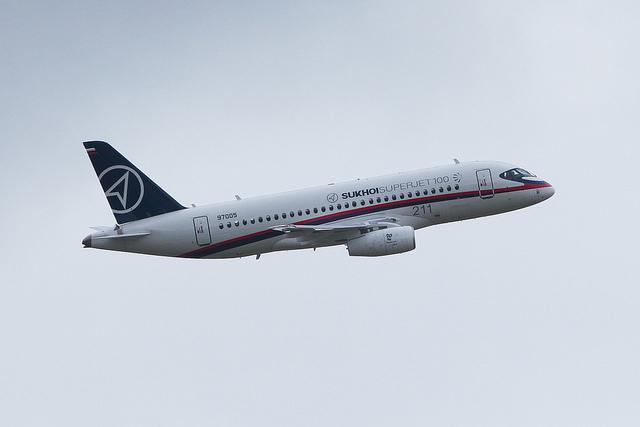What are the colors of the plane?
Write a very short answer. White, blue, red. Is the plane ready to land?
Keep it brief. No. How many engines are seen?
Write a very short answer. 1. Is the landing gear up or down?
Write a very short answer. Up. 